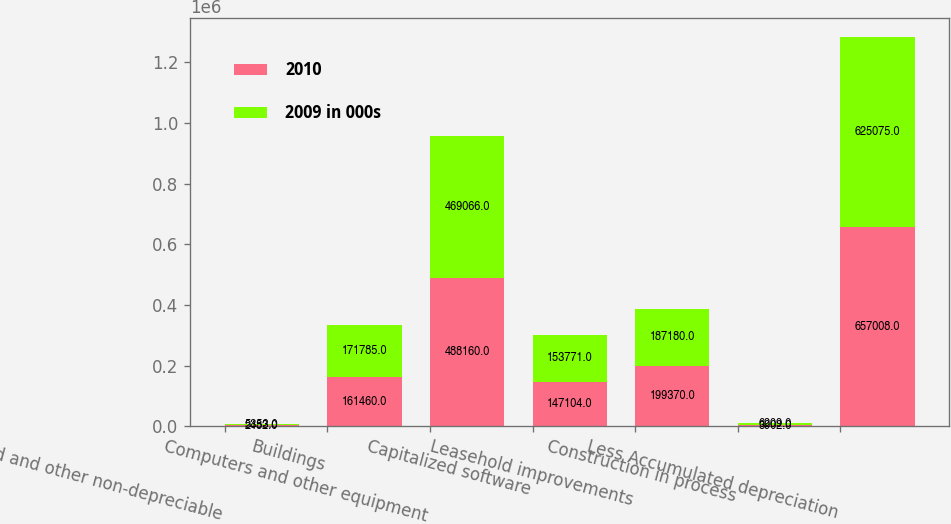Convert chart to OTSL. <chart><loc_0><loc_0><loc_500><loc_500><stacked_bar_chart><ecel><fcel>Land and other non-depreciable<fcel>Buildings<fcel>Computers and other equipment<fcel>Capitalized software<fcel>Leasehold improvements<fcel>Construction in process<fcel>Less Accumulated depreciation<nl><fcel>2010<fcel>2482<fcel>161460<fcel>488160<fcel>147104<fcel>199370<fcel>3902<fcel>657008<nl><fcel>2009 in 000s<fcel>5353<fcel>171785<fcel>469066<fcel>153771<fcel>187180<fcel>6209<fcel>625075<nl></chart> 